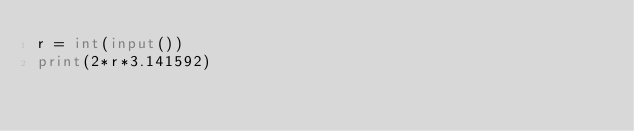<code> <loc_0><loc_0><loc_500><loc_500><_Python_>r = int(input())
print(2*r*3.141592)</code> 